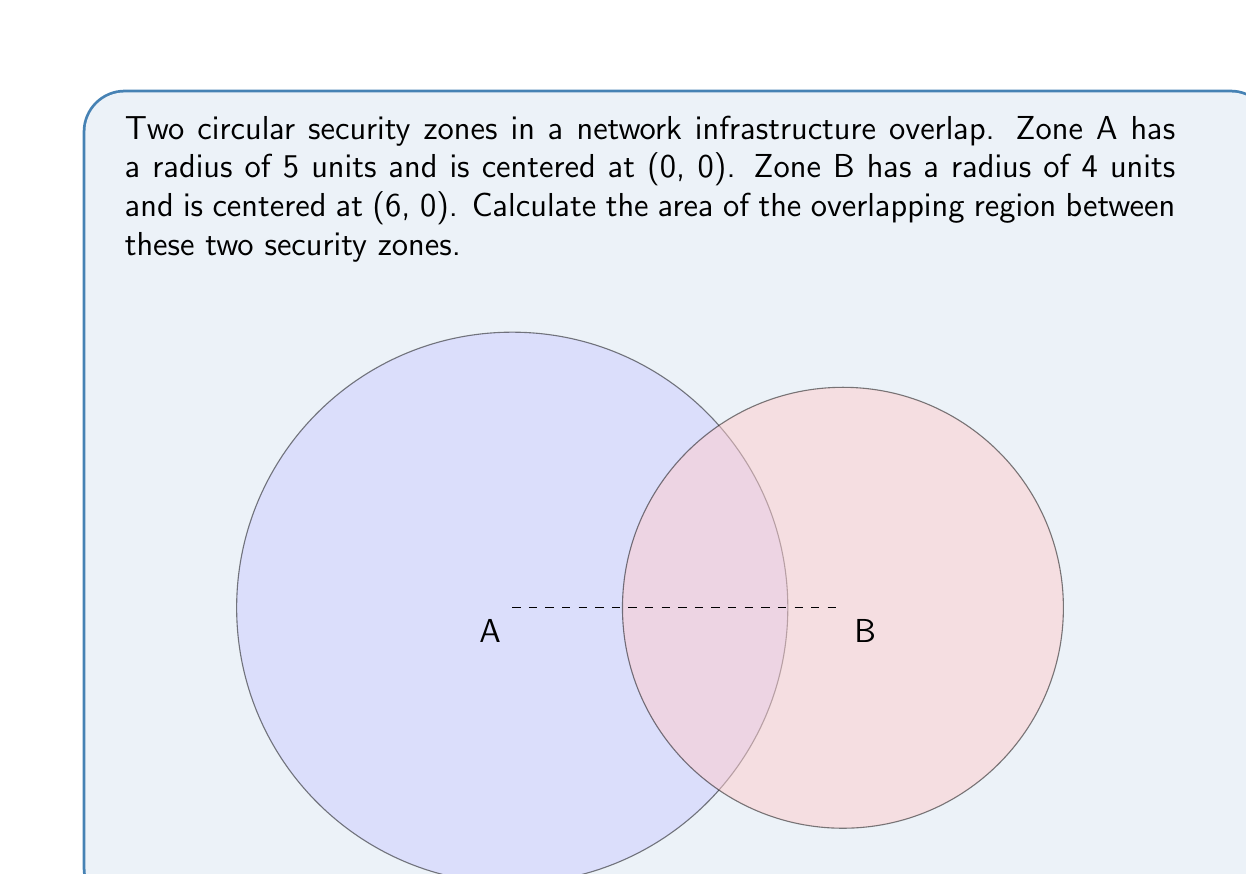Help me with this question. To solve this problem, we'll use the formula for the area of overlap between two circles. Let's break it down step-by-step:

1) First, we need to calculate the distance between the centers of the circles:
   $d = \sqrt{(x_2-x_1)^2 + (y_2-y_1)^2} = \sqrt{(6-0)^2 + (0-0)^2} = 6$

2) Now, we use the formula for the area of overlap:
   $$A = r_1^2 \arccos(\frac{d^2 + r_1^2 - r_2^2}{2dr_1}) + r_2^2 \arccos(\frac{d^2 + r_2^2 - r_1^2}{2dr_2}) - \frac{1}{2}\sqrt{(-d+r_1+r_2)(d+r_1-r_2)(d-r_1+r_2)(d+r_1+r_2)}$$

3) Let's substitute our values:
   $r_1 = 5$, $r_2 = 4$, $d = 6$

4) Calculate each part:
   $$\arccos(\frac{6^2 + 5^2 - 4^2}{2 \cdot 6 \cdot 5}) = \arccos(0.9583) = 0.2900$$
   $$\arccos(\frac{6^2 + 4^2 - 5^2}{2 \cdot 6 \cdot 4}) = \arccos(0.7083) = 0.7741$$
   $$\sqrt{(-6+5+4)(6+5-4)(6-5+4)(6+5+4)} = \sqrt{3 \cdot 7 \cdot 5 \cdot 15} = 18.3712$$

5) Now, put it all together:
   $$A = 5^2 \cdot 0.2900 + 4^2 \cdot 0.7741 - \frac{1}{2} \cdot 18.3712$$
   $$A = 7.2500 + 12.3856 - 9.1856 = 10.4500$$

Thus, the area of overlap is approximately 10.45 square units.
Answer: $10.45$ square units 